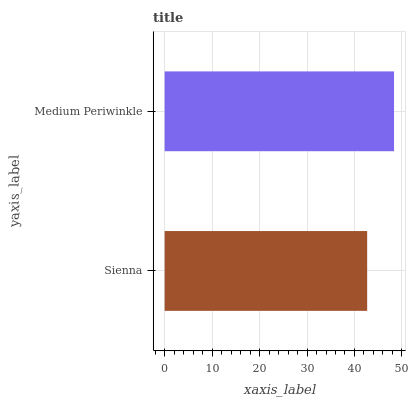Is Sienna the minimum?
Answer yes or no. Yes. Is Medium Periwinkle the maximum?
Answer yes or no. Yes. Is Medium Periwinkle the minimum?
Answer yes or no. No. Is Medium Periwinkle greater than Sienna?
Answer yes or no. Yes. Is Sienna less than Medium Periwinkle?
Answer yes or no. Yes. Is Sienna greater than Medium Periwinkle?
Answer yes or no. No. Is Medium Periwinkle less than Sienna?
Answer yes or no. No. Is Medium Periwinkle the high median?
Answer yes or no. Yes. Is Sienna the low median?
Answer yes or no. Yes. Is Sienna the high median?
Answer yes or no. No. Is Medium Periwinkle the low median?
Answer yes or no. No. 